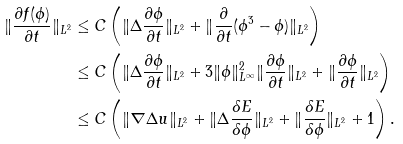<formula> <loc_0><loc_0><loc_500><loc_500>\| \frac { \partial f ( \phi ) } { \partial t } \| _ { L ^ { 2 } } & \leq C \left ( \| \Delta \frac { \partial \phi } { \partial t } \| _ { L ^ { 2 } } + \| \frac { \partial } { \partial t } ( \phi ^ { 3 } - \phi ) \| _ { L ^ { 2 } } \right ) \\ & \leq C \left ( \| \Delta \frac { \partial \phi } { \partial t } \| _ { L ^ { 2 } } + 3 \| \phi \| _ { L ^ { \infty } } ^ { 2 } \| \frac { \partial \phi } { \partial t } \| _ { L ^ { 2 } } + \| \frac { \partial \phi } { \partial t } \| _ { L ^ { 2 } } \right ) \\ & \leq C \left ( \| \nabla \Delta u \| _ { L ^ { 2 } } + \| \Delta \frac { \delta E } { \delta \phi } \| _ { L ^ { 2 } } + \| \frac { \delta E } { \delta \phi } \| _ { L ^ { 2 } } + 1 \right ) .</formula> 